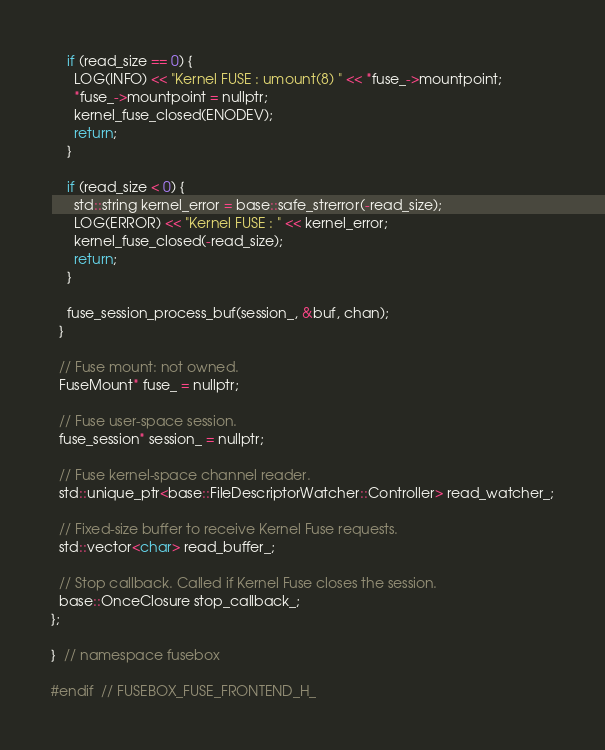Convert code to text. <code><loc_0><loc_0><loc_500><loc_500><_C_>
    if (read_size == 0) {
      LOG(INFO) << "Kernel FUSE : umount(8) " << *fuse_->mountpoint;
      *fuse_->mountpoint = nullptr;
      kernel_fuse_closed(ENODEV);
      return;
    }

    if (read_size < 0) {
      std::string kernel_error = base::safe_strerror(-read_size);
      LOG(ERROR) << "Kernel FUSE : " << kernel_error;
      kernel_fuse_closed(-read_size);
      return;
    }

    fuse_session_process_buf(session_, &buf, chan);
  }

  // Fuse mount: not owned.
  FuseMount* fuse_ = nullptr;

  // Fuse user-space session.
  fuse_session* session_ = nullptr;

  // Fuse kernel-space channel reader.
  std::unique_ptr<base::FileDescriptorWatcher::Controller> read_watcher_;

  // Fixed-size buffer to receive Kernel Fuse requests.
  std::vector<char> read_buffer_;

  // Stop callback. Called if Kernel Fuse closes the session.
  base::OnceClosure stop_callback_;
};

}  // namespace fusebox

#endif  // FUSEBOX_FUSE_FRONTEND_H_
</code> 